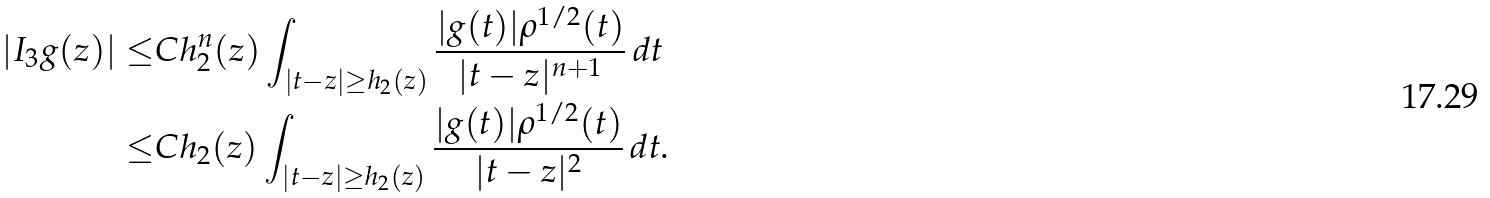<formula> <loc_0><loc_0><loc_500><loc_500>| I _ { 3 } g ( z ) | \leq & C h _ { 2 } ^ { n } ( z ) \int _ { | t - z | \geq h _ { 2 } ( z ) } \frac { | g ( t ) | \rho ^ { 1 / 2 } ( t ) } { | t - z | ^ { n + 1 } } \, d t \\ \leq & C h _ { 2 } ( z ) \int _ { | t - z | \geq h _ { 2 } ( z ) } \frac { | g ( t ) | \rho ^ { 1 / 2 } ( t ) } { | t - z | ^ { 2 } } \, d t .</formula> 